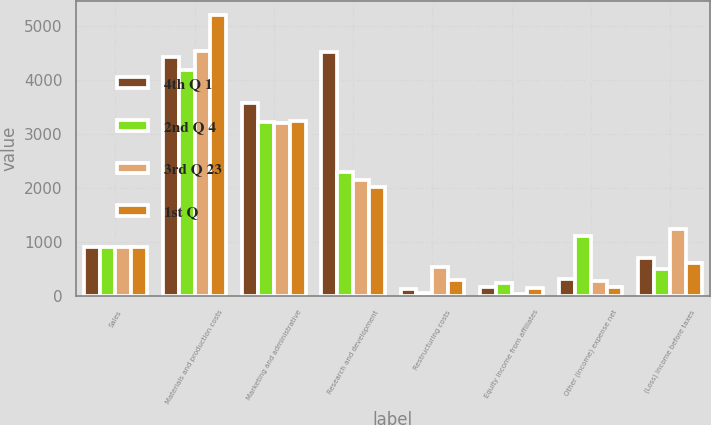Convert chart. <chart><loc_0><loc_0><loc_500><loc_500><stacked_bar_chart><ecel><fcel>Sales<fcel>Materials and production costs<fcel>Marketing and administrative<fcel>Research and development<fcel>Restructuring costs<fcel>Equity income from affiliates<fcel>Other (income) expense net<fcel>(Loss) income before taxes<nl><fcel>4th Q 1<fcel>904.5<fcel>4440<fcel>3579<fcel>4517<fcel>121<fcel>171<fcel>309<fcel>701<nl><fcel>2nd Q 4<fcel>904.5<fcel>4191<fcel>3218<fcel>2296<fcel>50<fcel>236<fcel>1108<fcel>498<nl><fcel>3rd Q 23<fcel>904.5<fcel>4549<fcel>3203<fcel>2151<fcel>526<fcel>43<fcel>281<fcel>1241<nl><fcel>1st Q<fcel>904.5<fcel>5216<fcel>3246<fcel>2027<fcel>288<fcel>138<fcel>167<fcel>616<nl></chart> 